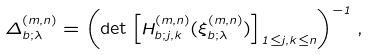Convert formula to latex. <formula><loc_0><loc_0><loc_500><loc_500>\Delta ^ { ( m , n ) } _ { b ; \lambda } = \left ( \det \left [ H ^ { ( m , n ) } _ { b ; j , k } ( \xi ^ { ( m , n ) } _ { b ; \lambda } ) \right ] _ { 1 \leq j , k \leq n } \right ) ^ { - 1 } ,</formula> 